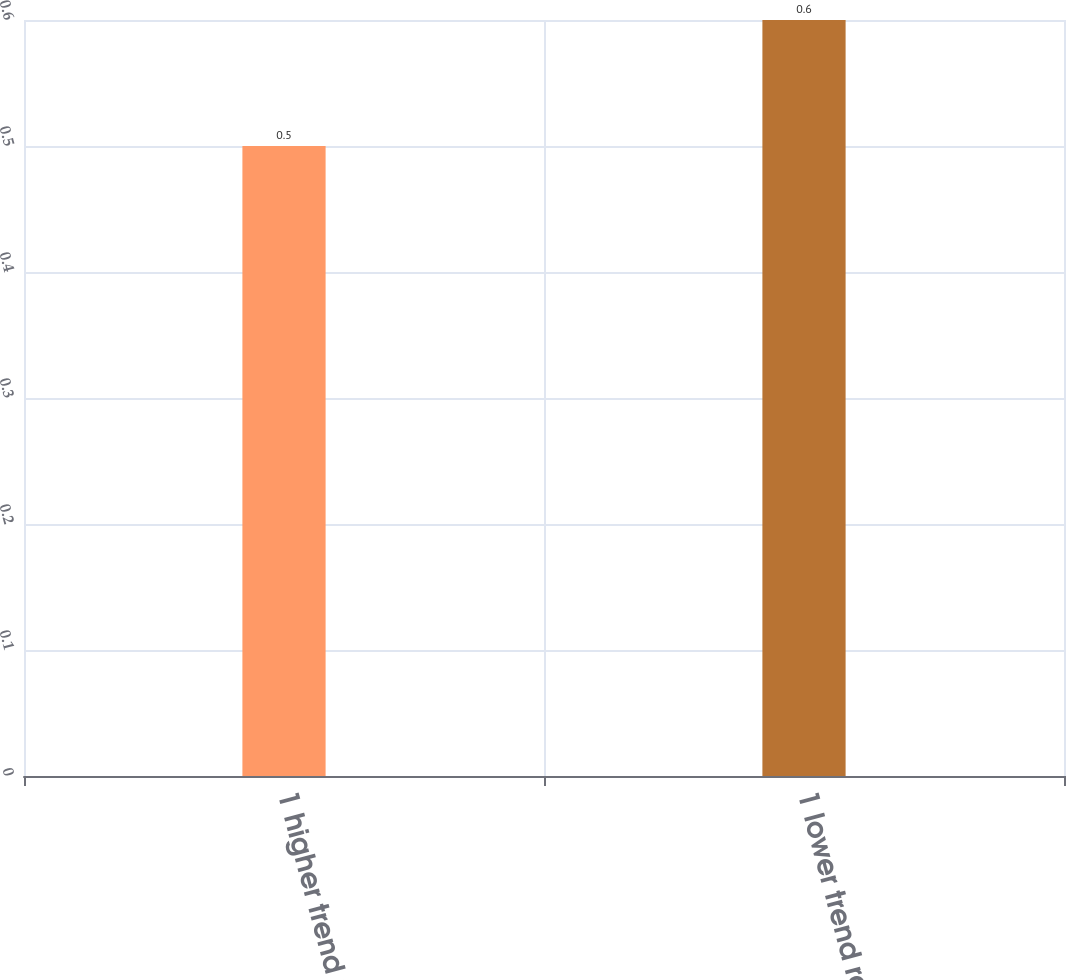Convert chart to OTSL. <chart><loc_0><loc_0><loc_500><loc_500><bar_chart><fcel>1 higher trend rate<fcel>1 lower trend rate<nl><fcel>0.5<fcel>0.6<nl></chart> 